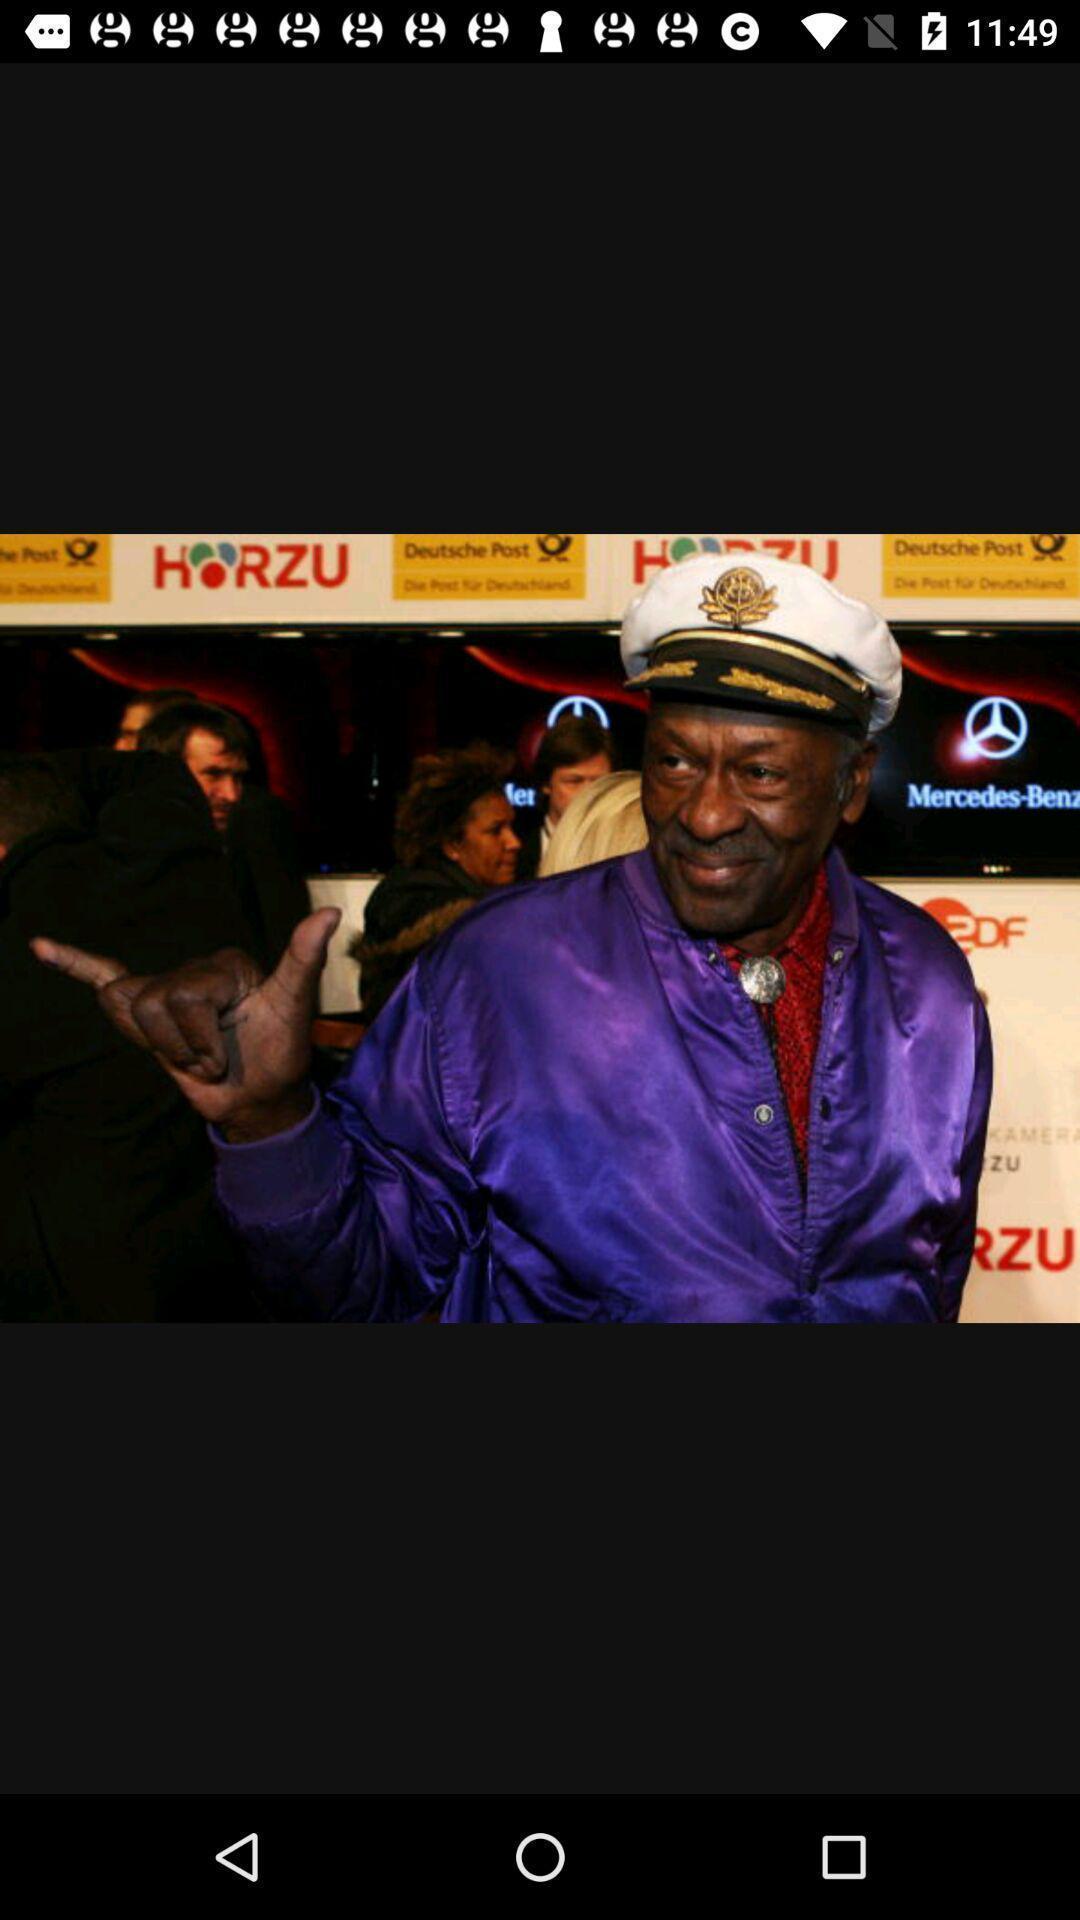What can you discern from this picture? Screen displaying a photo of a man. 